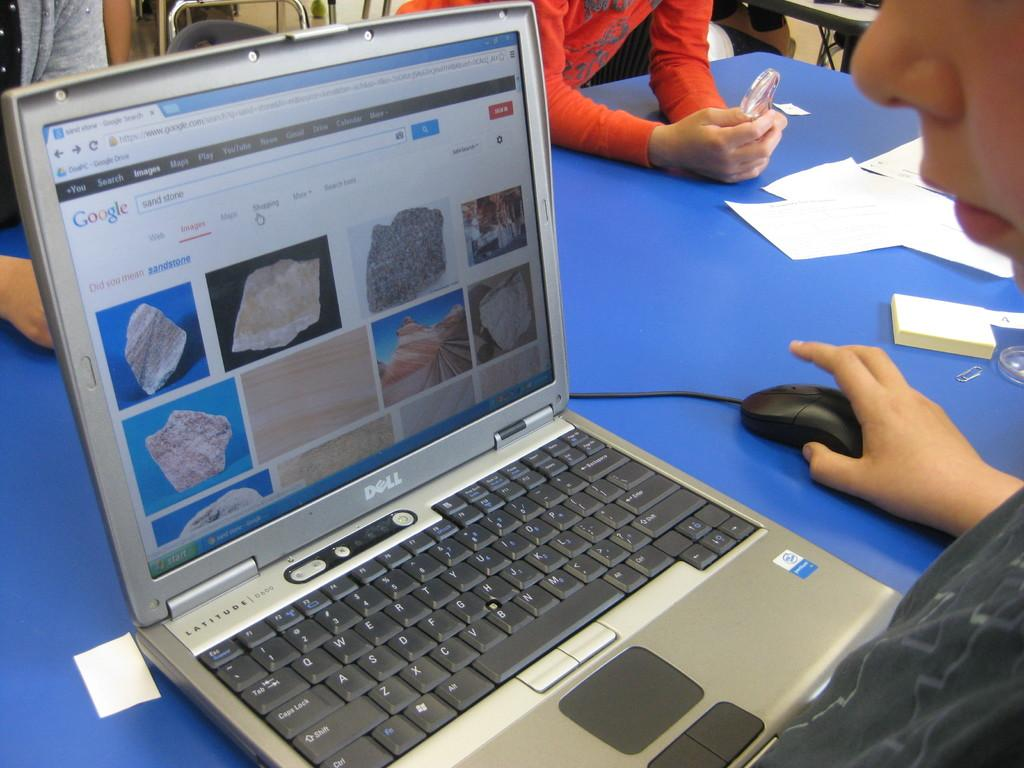<image>
Give a short and clear explanation of the subsequent image. A laptop computer displaying a Google search screen for sand stone 